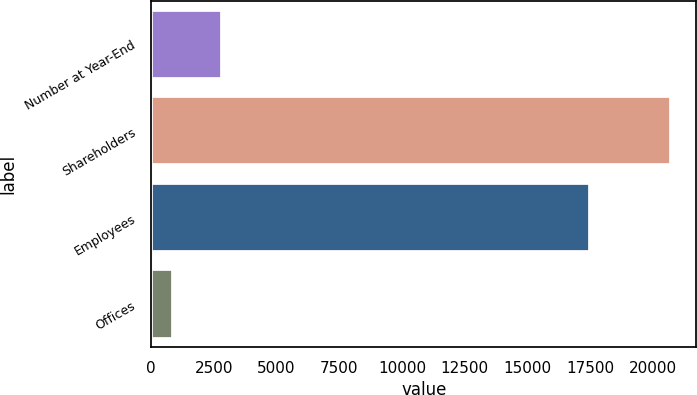<chart> <loc_0><loc_0><loc_500><loc_500><bar_chart><fcel>Number at Year-End<fcel>Shareholders<fcel>Employees<fcel>Offices<nl><fcel>2846<fcel>20693<fcel>17476<fcel>863<nl></chart> 